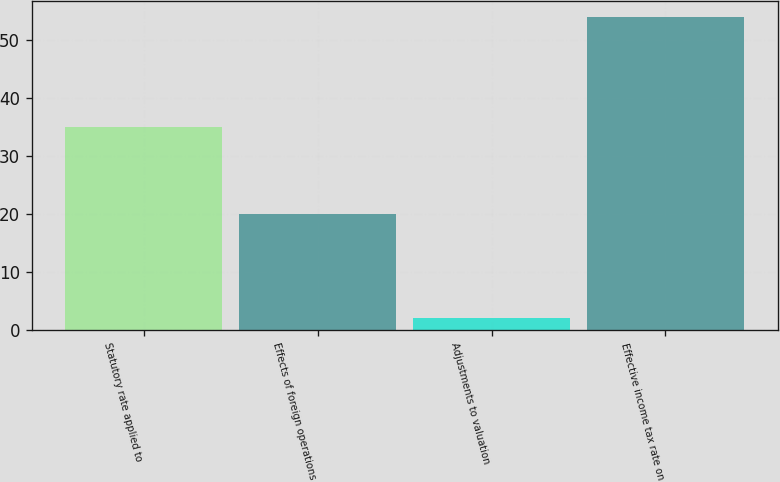<chart> <loc_0><loc_0><loc_500><loc_500><bar_chart><fcel>Statutory rate applied to<fcel>Effects of foreign operations<fcel>Adjustments to valuation<fcel>Effective income tax rate on<nl><fcel>35<fcel>20<fcel>2<fcel>54<nl></chart> 